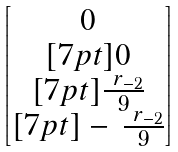<formula> <loc_0><loc_0><loc_500><loc_500>\begin{bmatrix} 0 \\ [ 7 p t ] 0 \\ [ 7 p t ] \frac { \ r _ { - 2 } } { 9 } \\ [ 7 p t ] - \, \frac { \ r _ { - 2 } } { 9 } \end{bmatrix}</formula> 